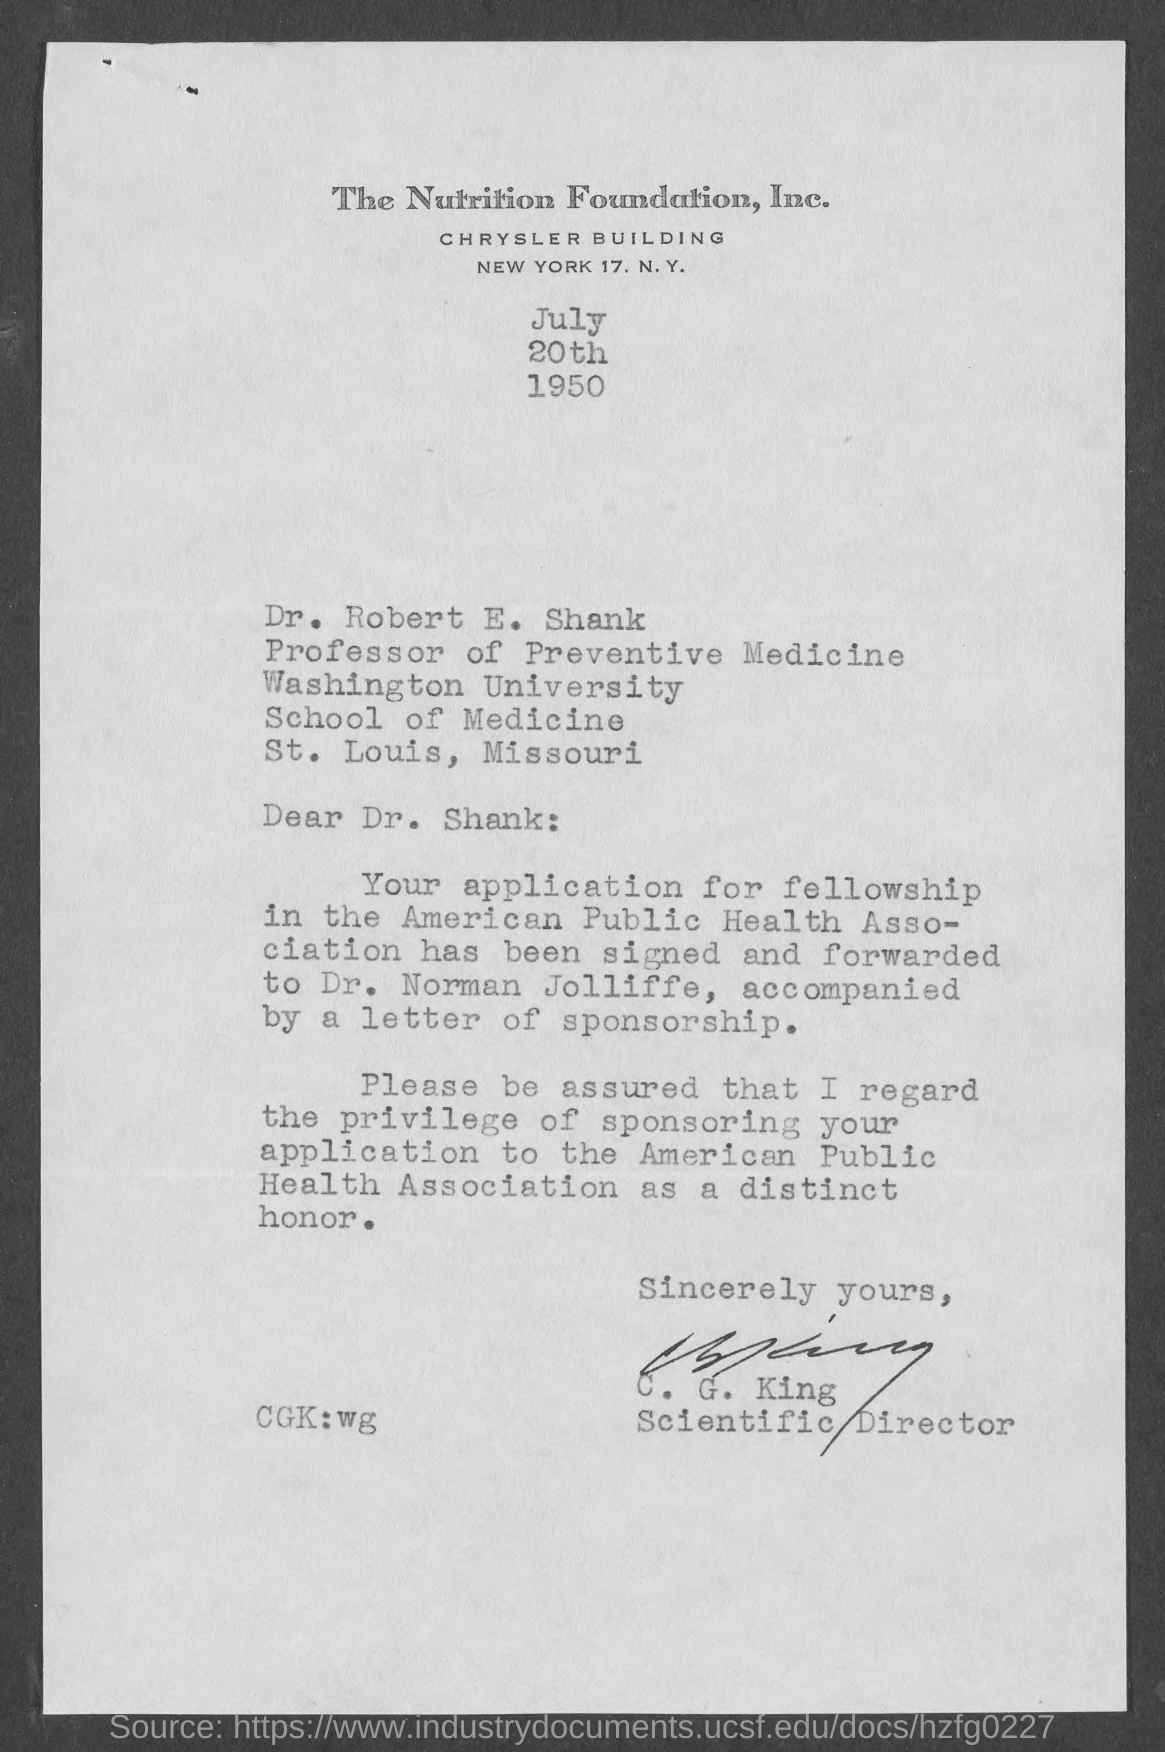What is the date mentioned in the given letter ?
Offer a very short reply. JULY 20TH 1950. What is the designation of dr. robert e. shank ?
Your answer should be compact. Professor of preventive medicine. Who's sign was there at the end of the letter ?
Give a very brief answer. C. G. KING. What is the designation of c.g.king ?
Make the answer very short. Scientific director. 